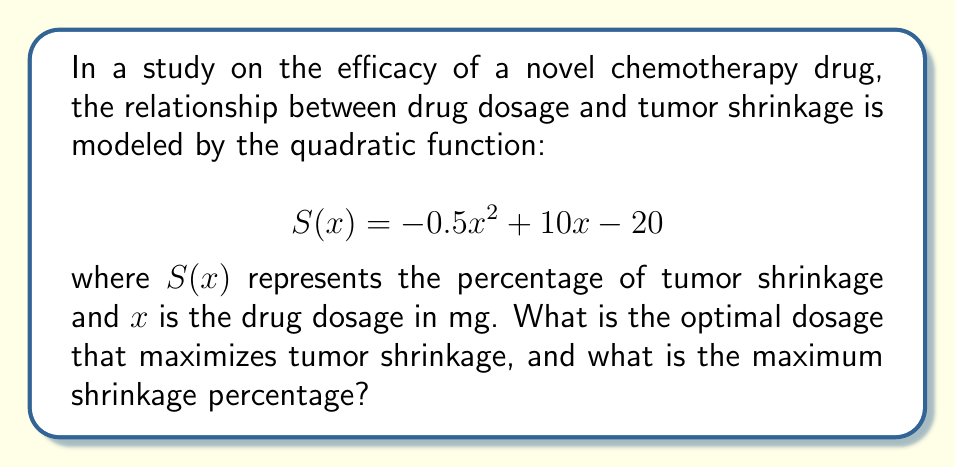Can you solve this math problem? To find the optimal dosage and maximum tumor shrinkage, we need to find the vertex of the quadratic function. The vertex represents the maximum point of the parabola.

1. For a quadratic function in the form $f(x) = ax^2 + bx + c$, the x-coordinate of the vertex is given by $x = -\frac{b}{2a}$.

2. In our function $S(x) = -0.5x^2 + 10x - 20$, we have:
   $a = -0.5$
   $b = 10$
   $c = -20$

3. Calculate the x-coordinate of the vertex:
   $x = -\frac{b}{2a} = -\frac{10}{2(-0.5)} = -\frac{10}{-1} = 10$

4. The optimal dosage is 10 mg.

5. To find the maximum shrinkage percentage, we substitute x = 10 into the original function:
   $S(10) = -0.5(10)^2 + 10(10) - 20$
   $= -0.5(100) + 100 - 20$
   $= -50 + 100 - 20$
   $= 30$

6. The maximum shrinkage percentage is 30%.

Therefore, the optimal dosage is 10 mg, which results in a maximum tumor shrinkage of 30%.
Answer: Optimal dosage: 10 mg; Maximum shrinkage: 30% 